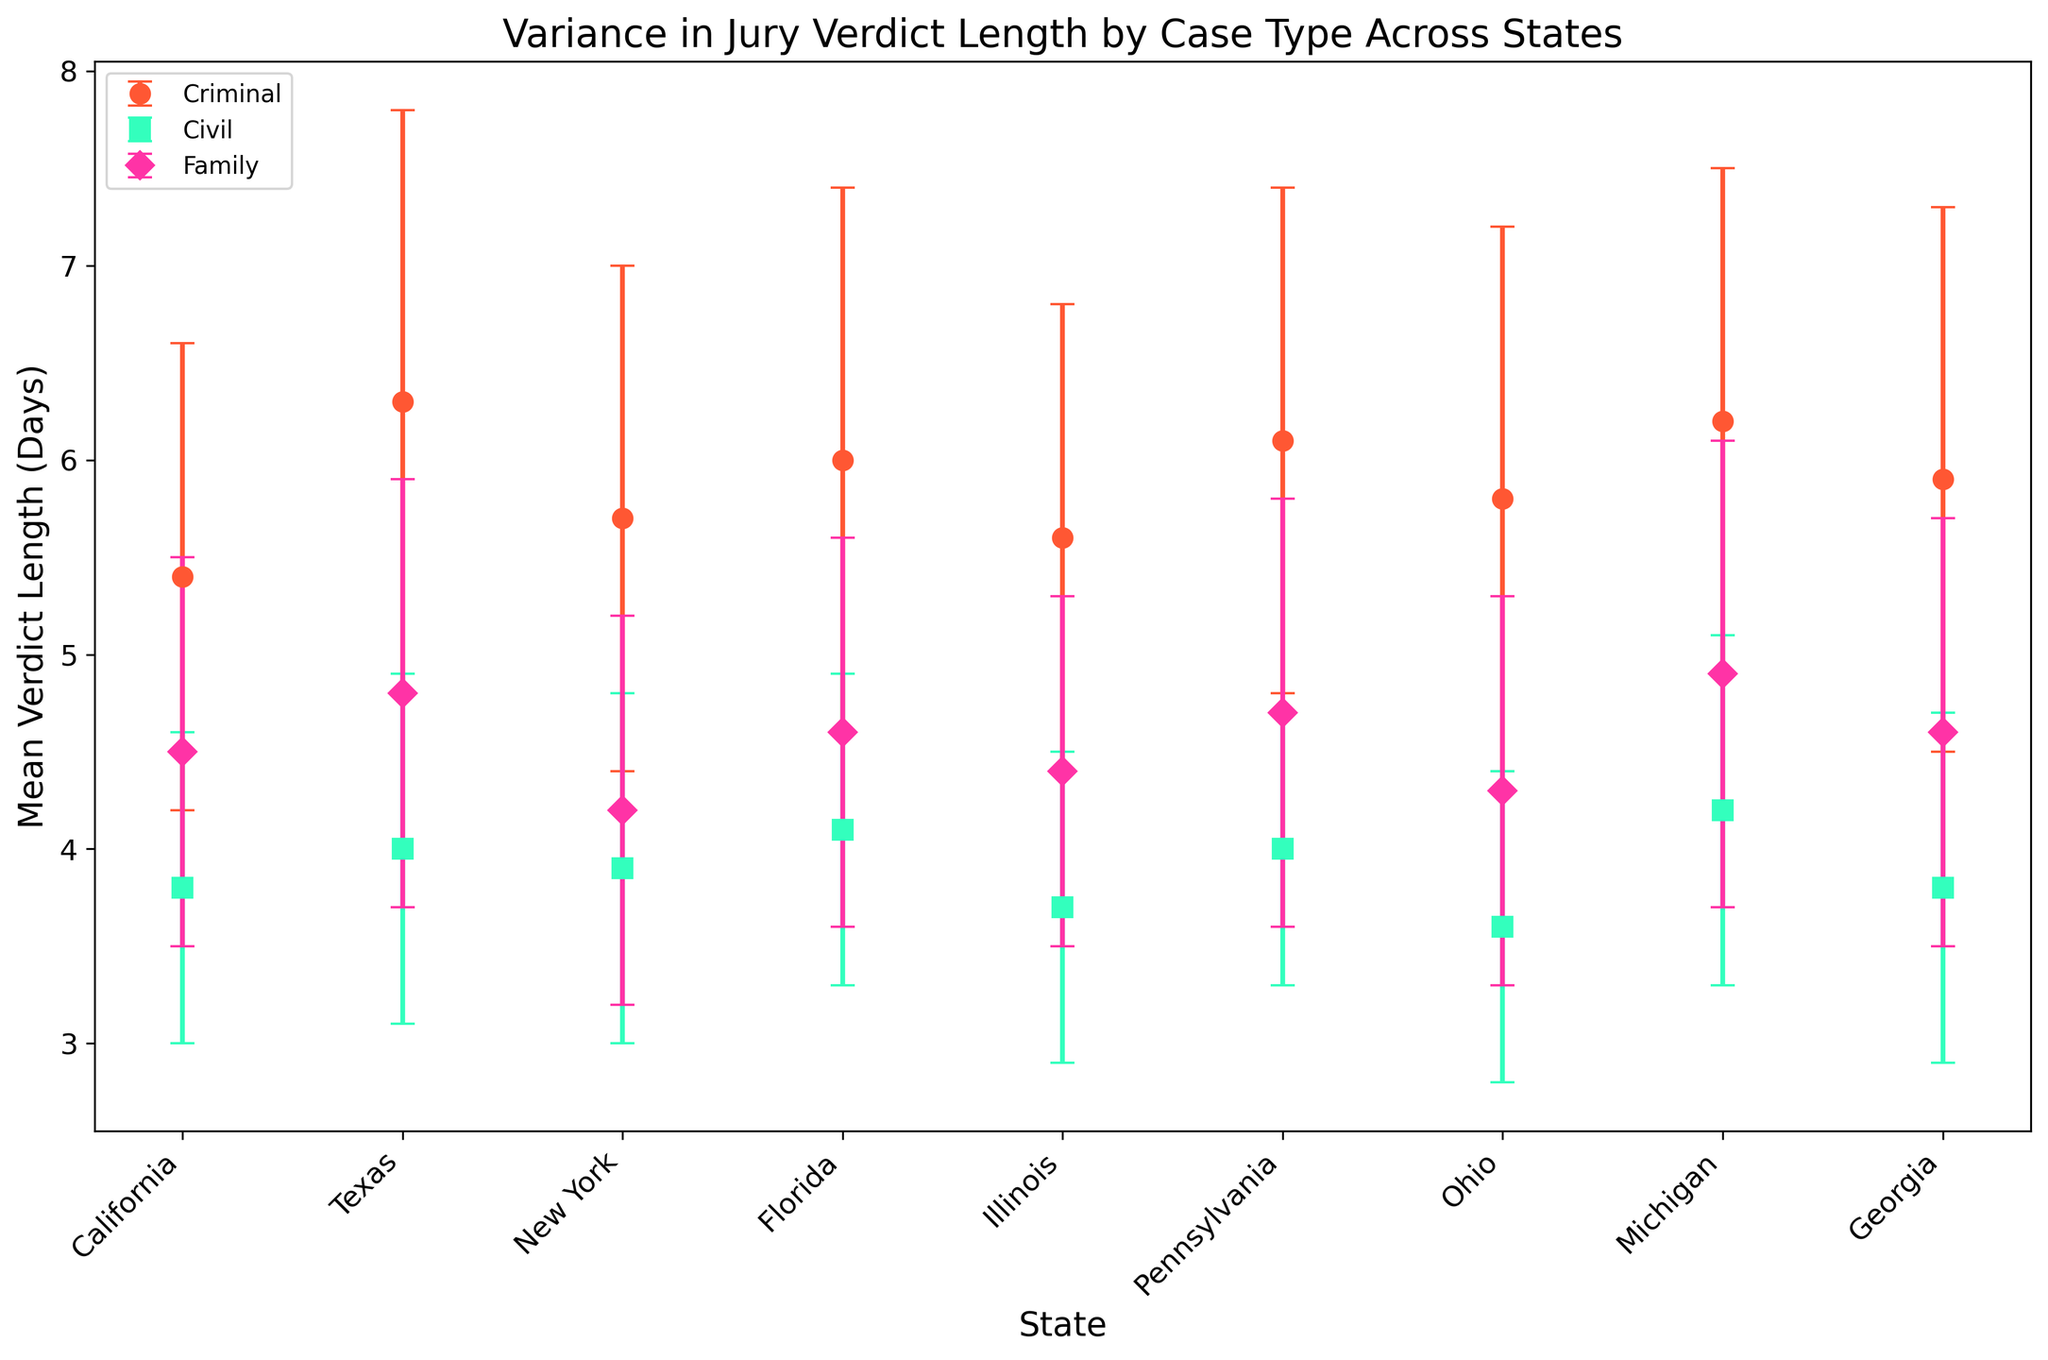What's the average mean verdict length for criminal cases across all states? To find the average mean verdict length for criminal cases, add up the mean verdict lengths for criminal cases in all states and divide by the number of states. Thus, (5.4 + 6.3 + 5.7 + 6.0 + 5.6 + 6.1 + 5.8 + 6.2 + 5.9) / 9 = 5.89
Answer: 5.89 Which state has the highest mean verdict length for family cases? By scanning through the family case data across all states, Michigan has the highest mean verdict length for family cases at 4.9 days
Answer: Michigan Which color represents civil cases, and what is their average standard deviation? By examining the legend, civil cases are represented by the green markers. The standard deviations are 0.8, 0.9, 0.9, 0.8, 0.8, 0.7, 0.8, 0.9, and 0.9 respectively. Their average is (0.8 + 0.9 + 0.9 + 0.8 + 0.8 + 0.7 + 0.8 + 0.9 + 0.9) / 9 = 0.83
Answer: Green, 0.83 Is there a state where the mean verdict length for all three case types is above 4 days? Checking mean verdict lengths for all three case types for each state, Texas has 6.3 (Criminal), 4.0 (Civil), and 4.8 (Family), all of which are above 4 days
Answer: Texas Which state shows the smallest spread (standard deviation) in verdict lengths for civil cases, and what is its value? From the data, Pennsylvania shows the smallest standard deviation for civil cases at 0.7 days
Answer: Pennsylvania What is the difference in mean verdict length for criminal cases between Texas and Ohio? The mean verdict length for criminal cases in Texas is 6.3, while it is 5.8 in Ohio. The difference is 6.3 - 5.8 = 0.5
Answer: 0.5 Compare the mean verdict length for family cases in Pennsylvania with the mean verdict length for civil cases in Michigan, what do you observe? The mean verdict length for family cases in Pennsylvania is 4.7, and for civil cases in Michigan, it is 4.2. Pennsylvania has a higher mean verdict length by 0.5 days
Answer: Pennsylvania higher by 0.5 days 